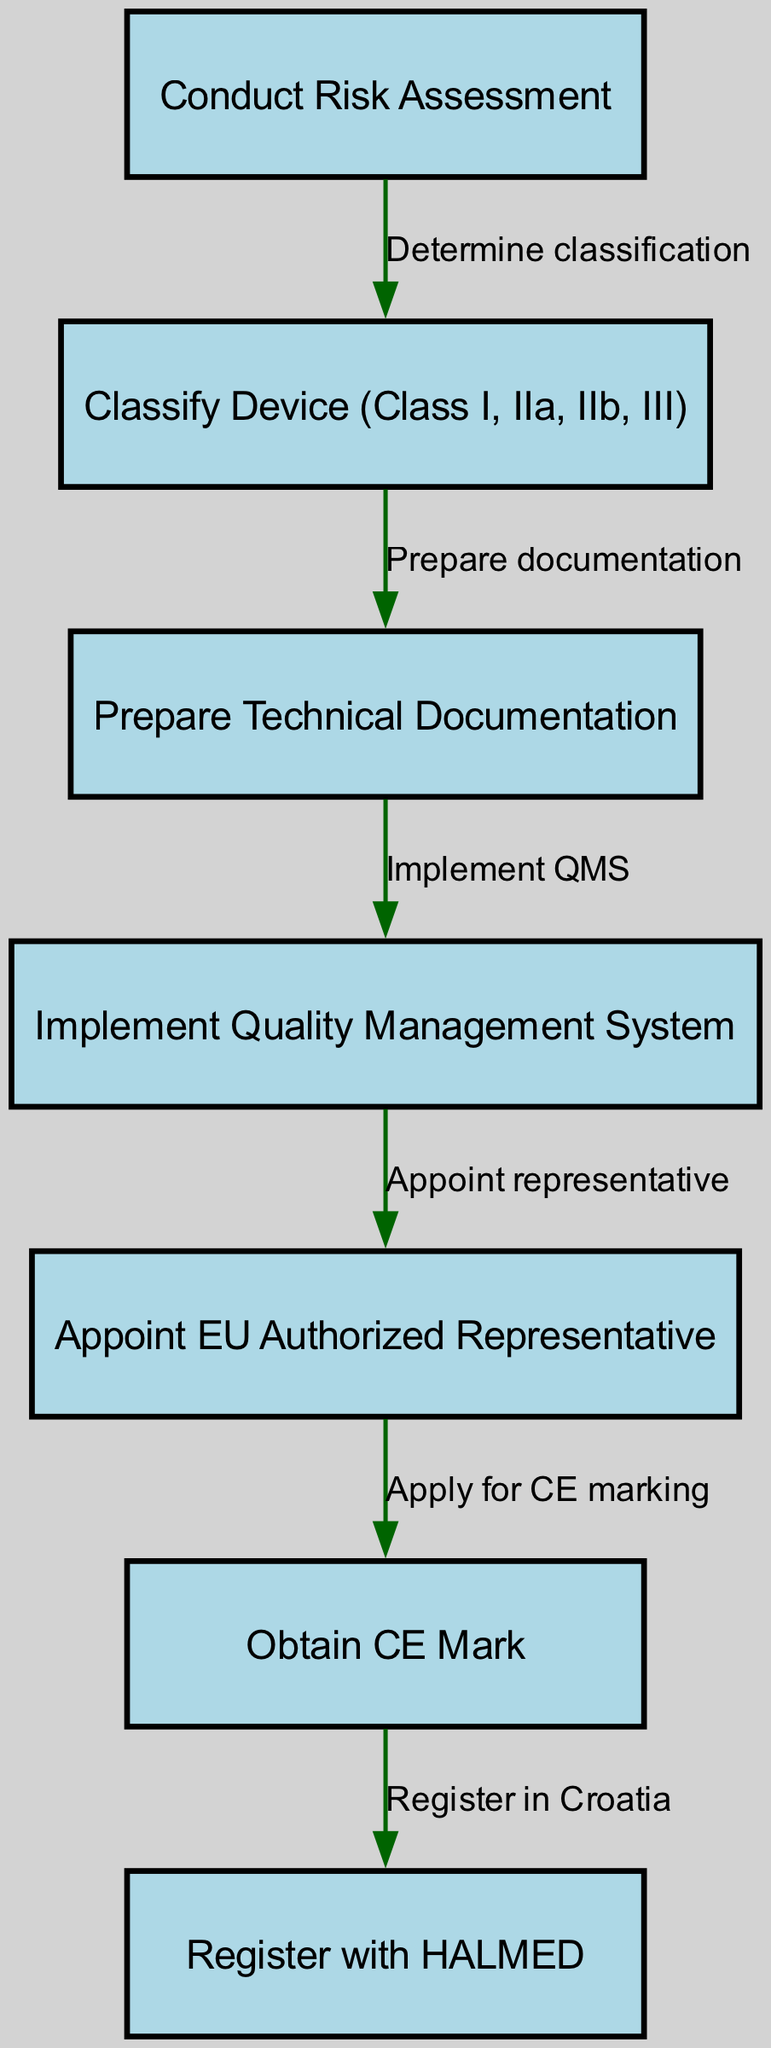What is the first step in the pathway? The diagram lists "Conduct Risk Assessment" as the first node, indicating it is the initial action required in the regulatory compliance pathway.
Answer: Conduct Risk Assessment How many nodes are present in the diagram? By counting the nodes listed in the data, we find there are seven distinct steps involved in the regulatory compliance pathway.
Answer: 7 What is the last action to be completed? The diagram shows "Register with HALMED" as the final step in the pathway, indicating that after obtaining the CE mark, registration is the concluding action.
Answer: Register with HALMED Which node follows "Prepare Technical Documentation"? The diagram indicates that the node "Implement Quality Management System" comes directly after "Prepare Technical Documentation," showing the sequence of tasks.
Answer: Implement Quality Management System What action is taken after "Appoint EU Authorized Representative"? Following "Appoint EU Authorized Representative," the next task according to the diagram is to "Obtain CE Mark," demonstrating the step following the appointment of a representative.
Answer: Obtain CE Mark How many edges are in the diagram? Counting the connections (edges) between the nodes, we find there are six edges that outline the relationships and sequences between the steps in the pathway.
Answer: 6 Which step requires determining classification? The node "Classify Device (Class I, IIa, IIb, III)" follows the step of "Conduct Risk Assessment" and is directly linked to it, showing its dependency on the risk assessment.
Answer: Classify Device (Class I, IIa, IIb, III) What is the relationship between "Obtain CE Mark" and "Register with HALMED"? The diagram illustrates that "Obtain CE Mark" is a prerequisite for "Register with HALMED," indicating that one must first acquire the CE mark before registration.
Answer: Apply for CE marking What is the second step in the pathway? The second node in the sequence from the diagram is "Classify Device (Class I, IIa, IIb, III)," as it follows the first step "Conduct Risk Assessment."
Answer: Classify Device (Class I, IIa, IIb, III) 